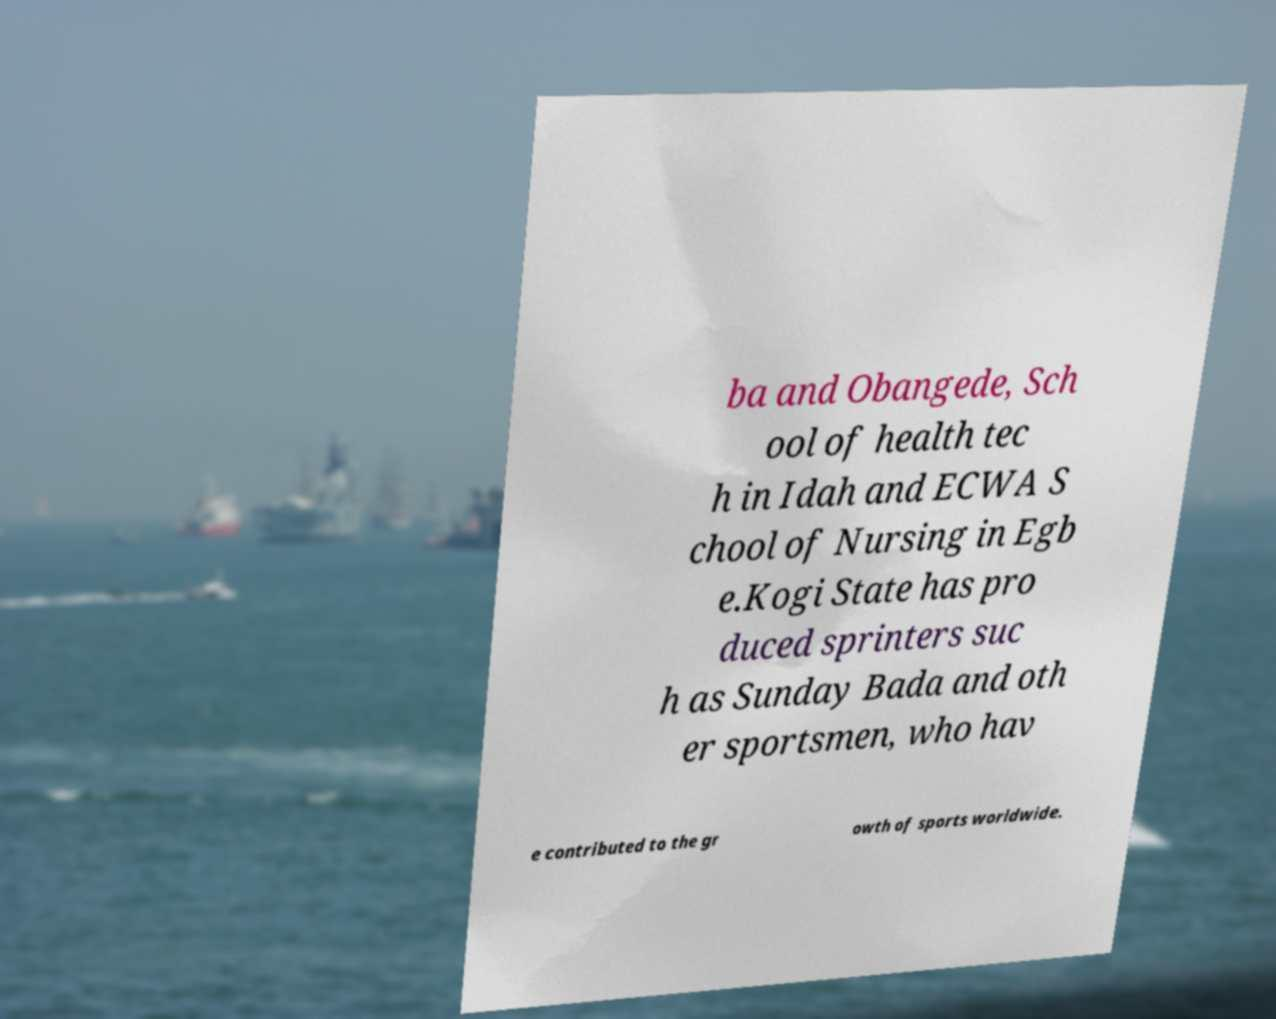There's text embedded in this image that I need extracted. Can you transcribe it verbatim? ba and Obangede, Sch ool of health tec h in Idah and ECWA S chool of Nursing in Egb e.Kogi State has pro duced sprinters suc h as Sunday Bada and oth er sportsmen, who hav e contributed to the gr owth of sports worldwide. 